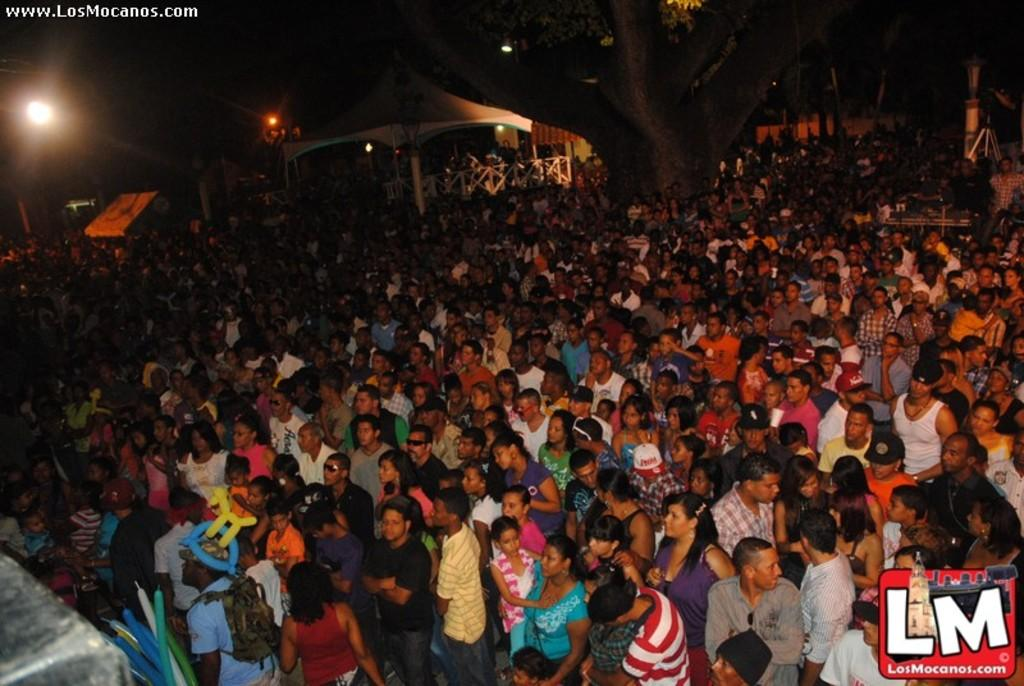How many people are in the image? There is a group of people in the image, but the exact number is not specified. What is the arrangement of the people in the image? The people are crowded at one place in the image. What can be seen in the background of the image? There is a tree and a tent in the background of the image. What is providing illumination in the image? There are lights visible in the image. What type of education is being taught in the field in the image? There is no field or education present in the image; it features a group of people crowded at one place with a tree and a tent in the background. What kind of glue is being used to stick the people together in the image? There is no glue or indication of people being stuck together in the image; they are simply crowded at one place. 